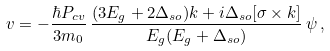<formula> <loc_0><loc_0><loc_500><loc_500>v = - \frac { \hbar { P } _ { c v } } { 3 m _ { 0 } } \, \frac { ( 3 E _ { g } + 2 \Delta _ { s o } ) k + i \Delta _ { s o } [ \sigma \times k ] } { E _ { g } ( E _ { g } + \Delta _ { s o } ) } \, \psi \, ,</formula> 